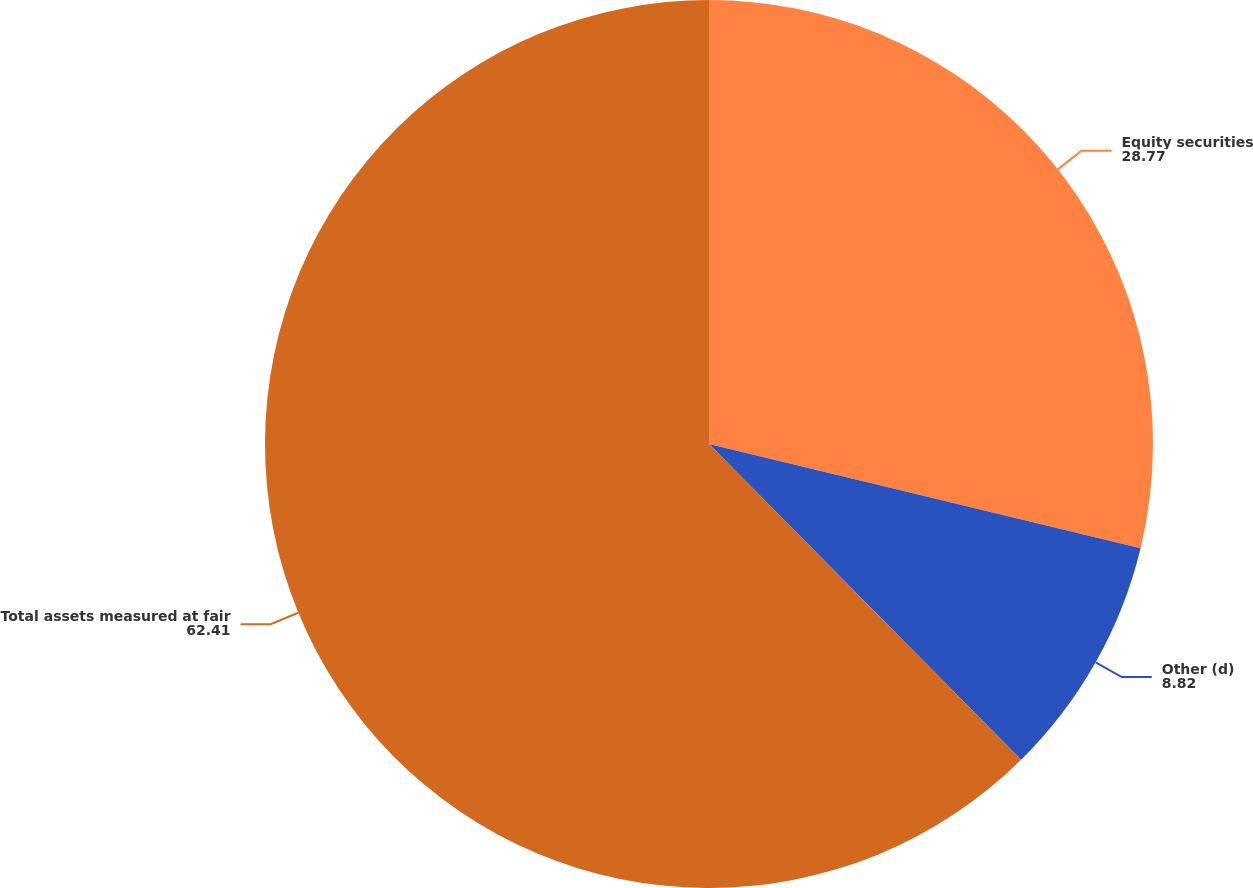Convert chart. <chart><loc_0><loc_0><loc_500><loc_500><pie_chart><fcel>Equity securities<fcel>Other (d)<fcel>Total assets measured at fair<nl><fcel>28.77%<fcel>8.82%<fcel>62.41%<nl></chart> 